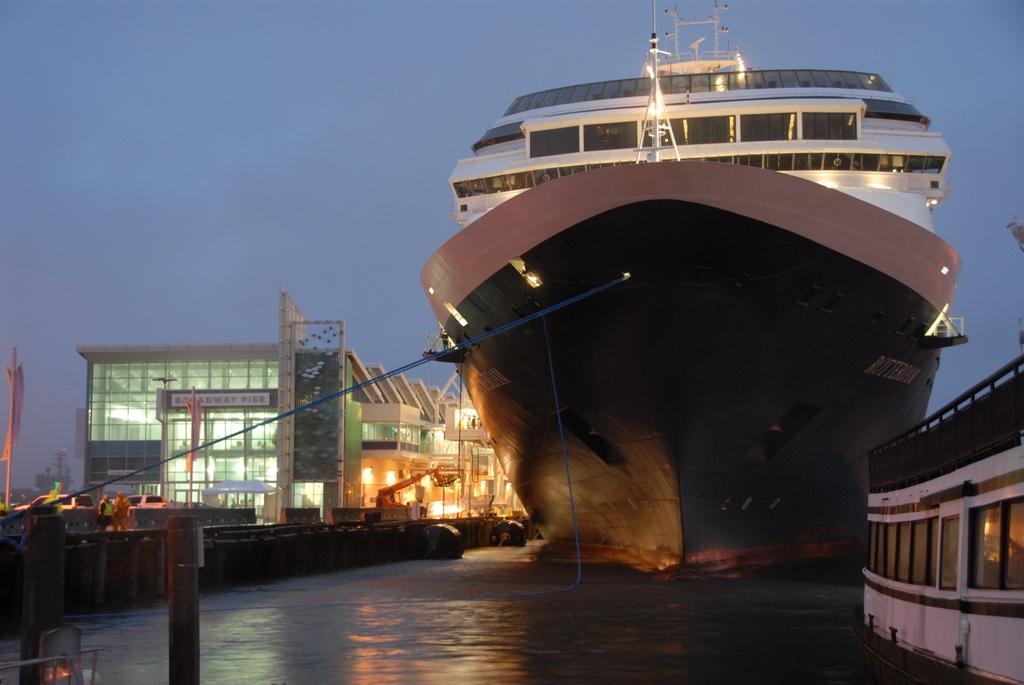What does the sign on the building say?
Your response must be concise. Broadway pier. 